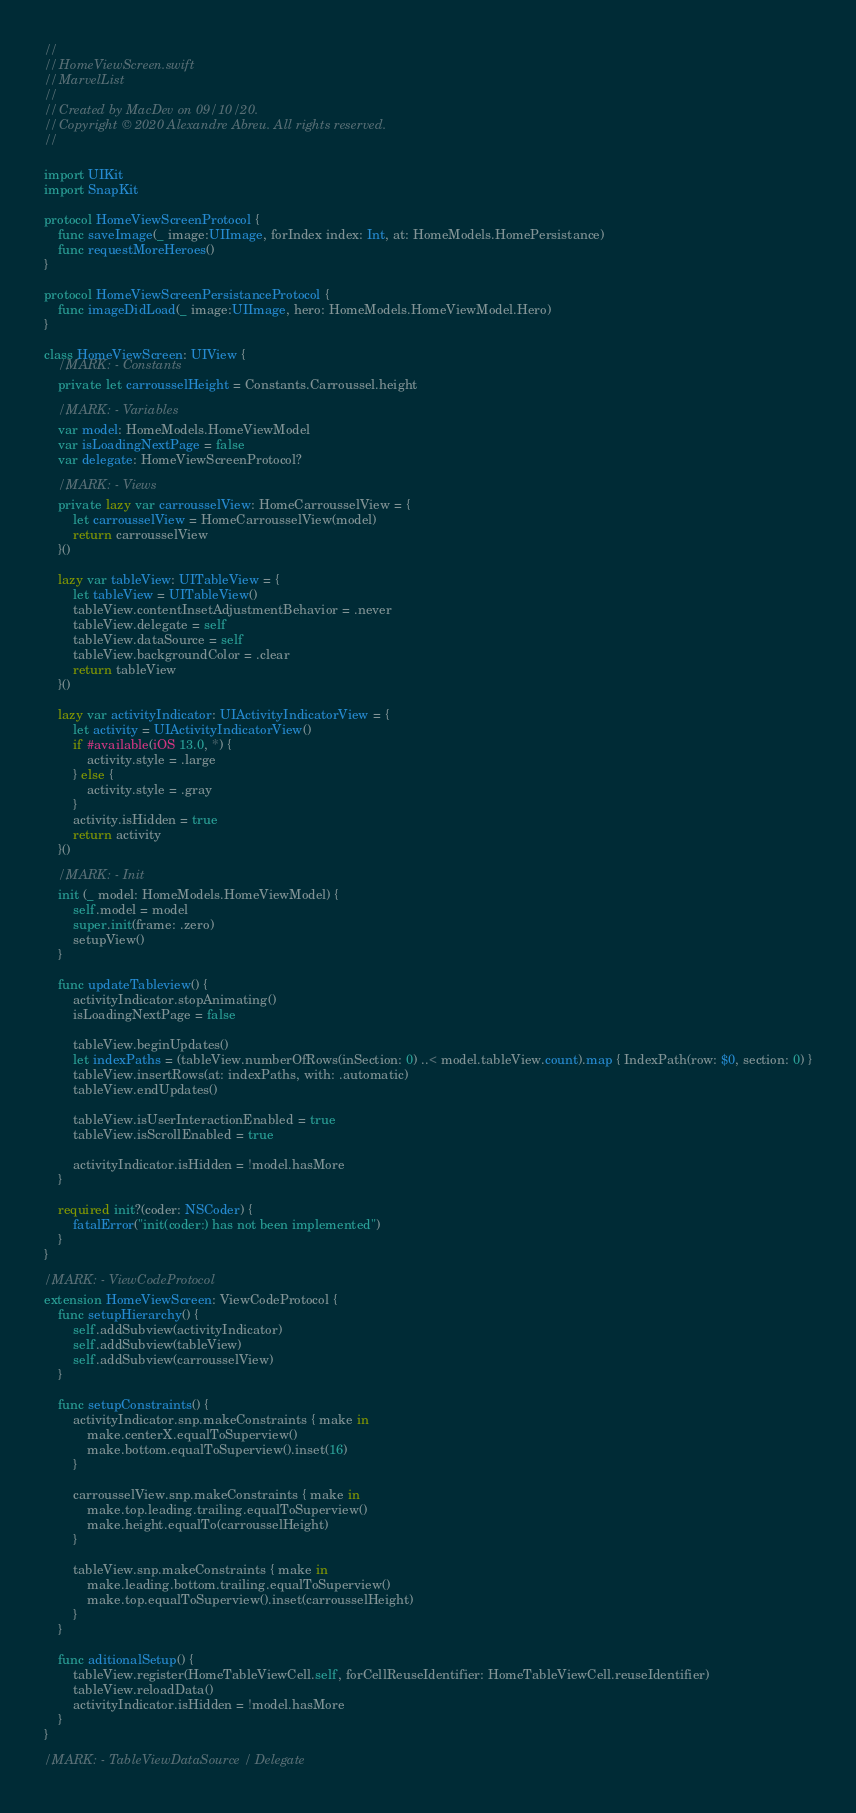<code> <loc_0><loc_0><loc_500><loc_500><_Swift_>//
//  HomeViewScreen.swift
//  MarvelList
//
//  Created by MacDev on 09/10/20.
//  Copyright © 2020 Alexandre Abreu. All rights reserved.
//

import UIKit
import SnapKit

protocol HomeViewScreenProtocol {
    func saveImage(_ image:UIImage, forIndex index: Int, at: HomeModels.HomePersistance)
    func requestMoreHeroes()
}

protocol HomeViewScreenPersistanceProtocol {
    func imageDidLoad(_ image:UIImage, hero: HomeModels.HomeViewModel.Hero)
}

class HomeViewScreen: UIView {
    //MARK: - Constants
    private let carrousselHeight = Constants.Carroussel.height
    
    //MARK: - Variables
    var model: HomeModels.HomeViewModel
    var isLoadingNextPage = false
    var delegate: HomeViewScreenProtocol?
    
    //MARK: - Views
    private lazy var carrousselView: HomeCarrousselView = {
        let carrousselView = HomeCarrousselView(model)
        return carrousselView
    }()
    
    lazy var tableView: UITableView = {
        let tableView = UITableView()
        tableView.contentInsetAdjustmentBehavior = .never
        tableView.delegate = self
        tableView.dataSource = self
        tableView.backgroundColor = .clear
        return tableView
    }()
    
    lazy var activityIndicator: UIActivityIndicatorView = {
        let activity = UIActivityIndicatorView()
        if #available(iOS 13.0, *) {
            activity.style = .large
        } else {
            activity.style = .gray
        }
        activity.isHidden = true
        return activity
    }()
    
    //MARK: - Init
    init (_ model: HomeModels.HomeViewModel) {
        self.model = model
        super.init(frame: .zero)
        setupView()
    }
    
    func updateTableview() {
        activityIndicator.stopAnimating()
        isLoadingNextPage = false
        
        tableView.beginUpdates()
        let indexPaths = (tableView.numberOfRows(inSection: 0) ..< model.tableView.count).map { IndexPath(row: $0, section: 0) }
        tableView.insertRows(at: indexPaths, with: .automatic)
        tableView.endUpdates()
        
        tableView.isUserInteractionEnabled = true
        tableView.isScrollEnabled = true
                   
        activityIndicator.isHidden = !model.hasMore
    }
    
    required init?(coder: NSCoder) {
        fatalError("init(coder:) has not been implemented")
    }
}

//MARK: - ViewCodeProtocol
extension HomeViewScreen: ViewCodeProtocol {
    func setupHierarchy() {
        self.addSubview(activityIndicator)
        self.addSubview(tableView)
        self.addSubview(carrousselView)
    }
    
    func setupConstraints() {
        activityIndicator.snp.makeConstraints { make in
            make.centerX.equalToSuperview()
            make.bottom.equalToSuperview().inset(16)
        }
        
        carrousselView.snp.makeConstraints { make in
            make.top.leading.trailing.equalToSuperview()
            make.height.equalTo(carrousselHeight)
        }
        
        tableView.snp.makeConstraints { make in
            make.leading.bottom.trailing.equalToSuperview()
            make.top.equalToSuperview().inset(carrousselHeight)
        }
    }
    
    func aditionalSetup() {
        tableView.register(HomeTableViewCell.self, forCellReuseIdentifier: HomeTableViewCell.reuseIdentifier)
        tableView.reloadData()
        activityIndicator.isHidden = !model.hasMore
    }
}

//MARK: - TableViewDataSource / Delegate</code> 